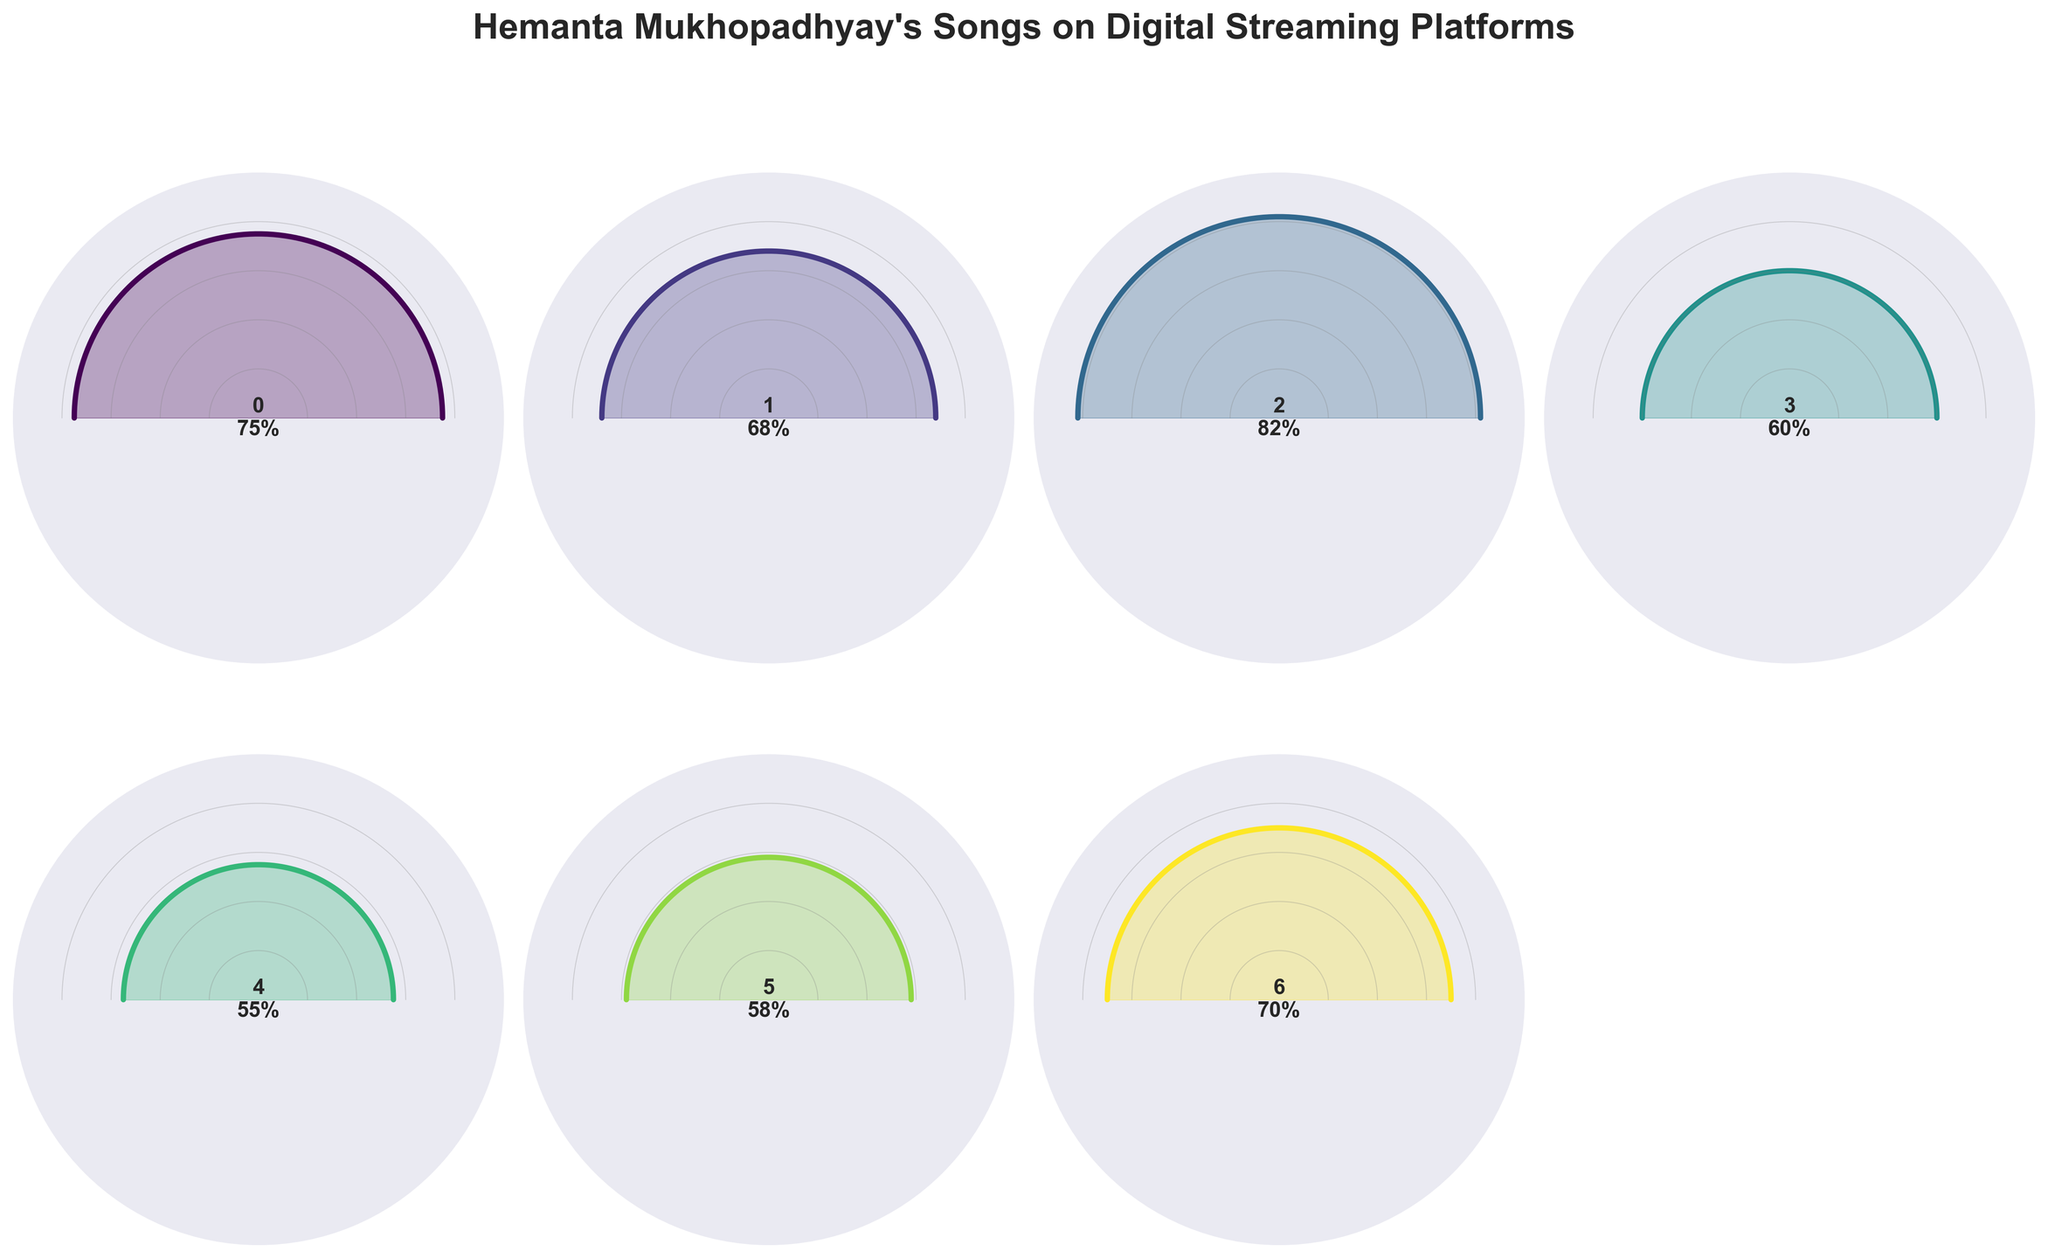how many digital streaming platforms are displayed in the figure? The figure shows gauge charts for different digital streaming platforms, and by counting the titles or each platform label in the figure, we can determine the number of platforms.
Answer: 7 which platform has the highest percentage of Hemanta Mukhopadhyay's songs? By visually inspecting the gauge charts, the highest percentage corresponds to the platform with the gauge reaching the furthest to the right.
Answer: YouTube Music what is the percentage range for Hemanta Mukhopadhyay's songs across all platforms? The minimum and maximum percentages can be identified by locating the smallest and largest values in the figure. Here, the lowest percentage is on Gaana (55%) and the highest is on YouTube Music (82%).
Answer: 55%-82% which platforms have a percentage below 60%? By examining the gauge charts, we can identify platforms where the gauge does not exceed the 60% mark. These platforms are Gaana, Wynk Music, and JioSaavn.
Answer: Gaana, Wynk Music, JioSaavn how much higher is the percentage of Hemanta Mukhopadhyay's songs on Spotify compared to Gaana? First, find the percentage on Spotify (75%) and Gaana (55%). Then, calculate the difference: 75% - 55% = 20%
Answer: 20% what is the average percentage of Hemanta Mukhopadhyay's songs across all the platforms? Add up all the percentages (75 + 68 + 82 + 60 + 55 + 58 + 70) and divide by the number of platforms (7): (75 + 68 + 82 + 60 + 55 + 58 + 70) / 7.
Answer: 66.86% which platform has a percentage closest to the average value? After calculating the average percentage (66.86%), compare each platform's percentage to determine the closest one. Apple Music at 68% is closest to the average.
Answer: Apple Music what is the total percentage for the platforms with more than 70%? Identify the platforms with percentages over 70% (YouTube Music, Spotify, Amazon Music), then sum their percentages: 82% + 75% + 70%.
Answer: 227% which platforms have a percentage between 60% and 70%? By examining the gauge charts, we identify platforms that fall within the 60%-70% range. These platforms are Apple Music and Amazon Music.
Answer: Apple Music, Amazon Music how is the percentage distribution visually represented in the figure? The figure uses radial gauge charts, with each platform's percentage represented by the extent to which the gauge fills from the center outward toward the edge of the circle.
Answer: Radial gauge charts 